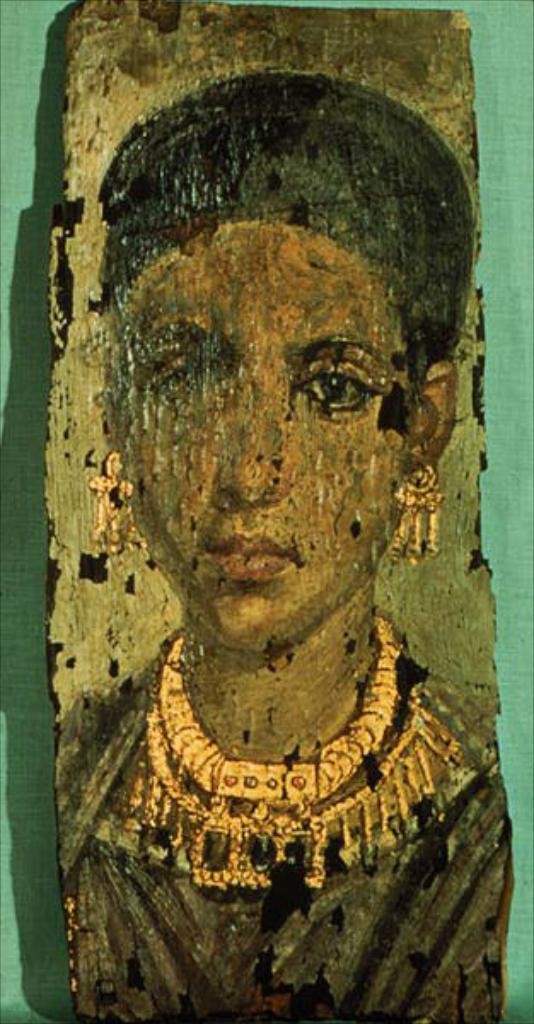What is shown on the board in the image? There is a depiction of a woman on the board. What color is the background of the image? The background of the image is green. How many bikes are parked next to the woman in the image? There are no bikes present in the image; it only shows a depiction of a woman on the board with a green background. What is the man doing in the image? There is no man present in the image; it only shows a depiction of a woman on the board with a green background. 